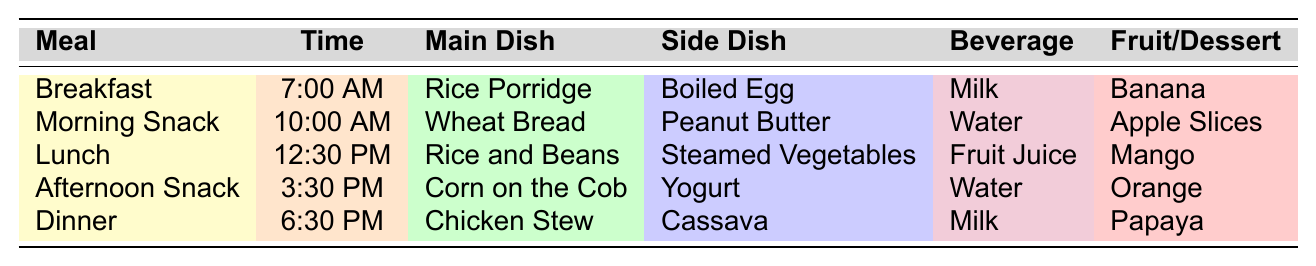What time is lunch served? The table shows that lunch is scheduled at 12:30 PM under the "Time" column for the "Lunch" row.
Answer: 12:30 PM What beverage is served with breakfast? According to the table under the "Breakfast" row, the beverage served is Milk.
Answer: Milk Is there any fruit served during the afternoon snack? The table lists "Fruit" under the "Afternoon Snack" row, which is Orange. This confirms that there is fruit served.
Answer: Yes What is the main dish served for dinner? The main dish for dinner is Chicken Stew, which can be found under the "Dinner" row in the "Main Dish" column.
Answer: Chicken Stew How many meals include milk? The table shows that Milk is served during both Breakfast and Dinner. Therefore, there are two meals that include milk.
Answer: 2 What are the side dishes for lunch and dinner combined? Lunch has Steamed Vegetables as the side dish and dinner has Cassava. Therefore, the combined side dishes are Steamed Vegetables and Cassava.
Answer: Steamed Vegetables and Cassava Do any meals serve water? The table indicates that water is served during both the Morning Snack and the Afternoon Snack, confirming that water is included in the meal schedule.
Answer: Yes Which meal has the same beverage as breakfast? Breakfast serves Milk as the beverage, and Dinner also serves Milk. Thus, Dinner is the meal that has the same beverage as breakfast.
Answer: Dinner What is the difference in time between morning snack and afternoon snack? Morning Snack is at 10:00 AM and Afternoon Snack is at 3:30 PM. The time difference is 5 hours and 30 minutes.
Answer: 5 hours and 30 minutes How many fruits are served in total throughout the day? The table lists a Banana for Breakfast, Apple Slices for Morning Snack, Mango for Lunch, Orange for Afternoon Snack, and Papaya for Dinner. This gives a total of 5 fruits served throughout the day.
Answer: 5 Which main dish is paired with the side dish "Boiled Egg"? The table specifies that "Boiled Egg" is the side dish served with the main dish "Rice Porridge" during Breakfast. Therefore, Rice Porridge accompanies the Boiled Egg.
Answer: Rice Porridge 